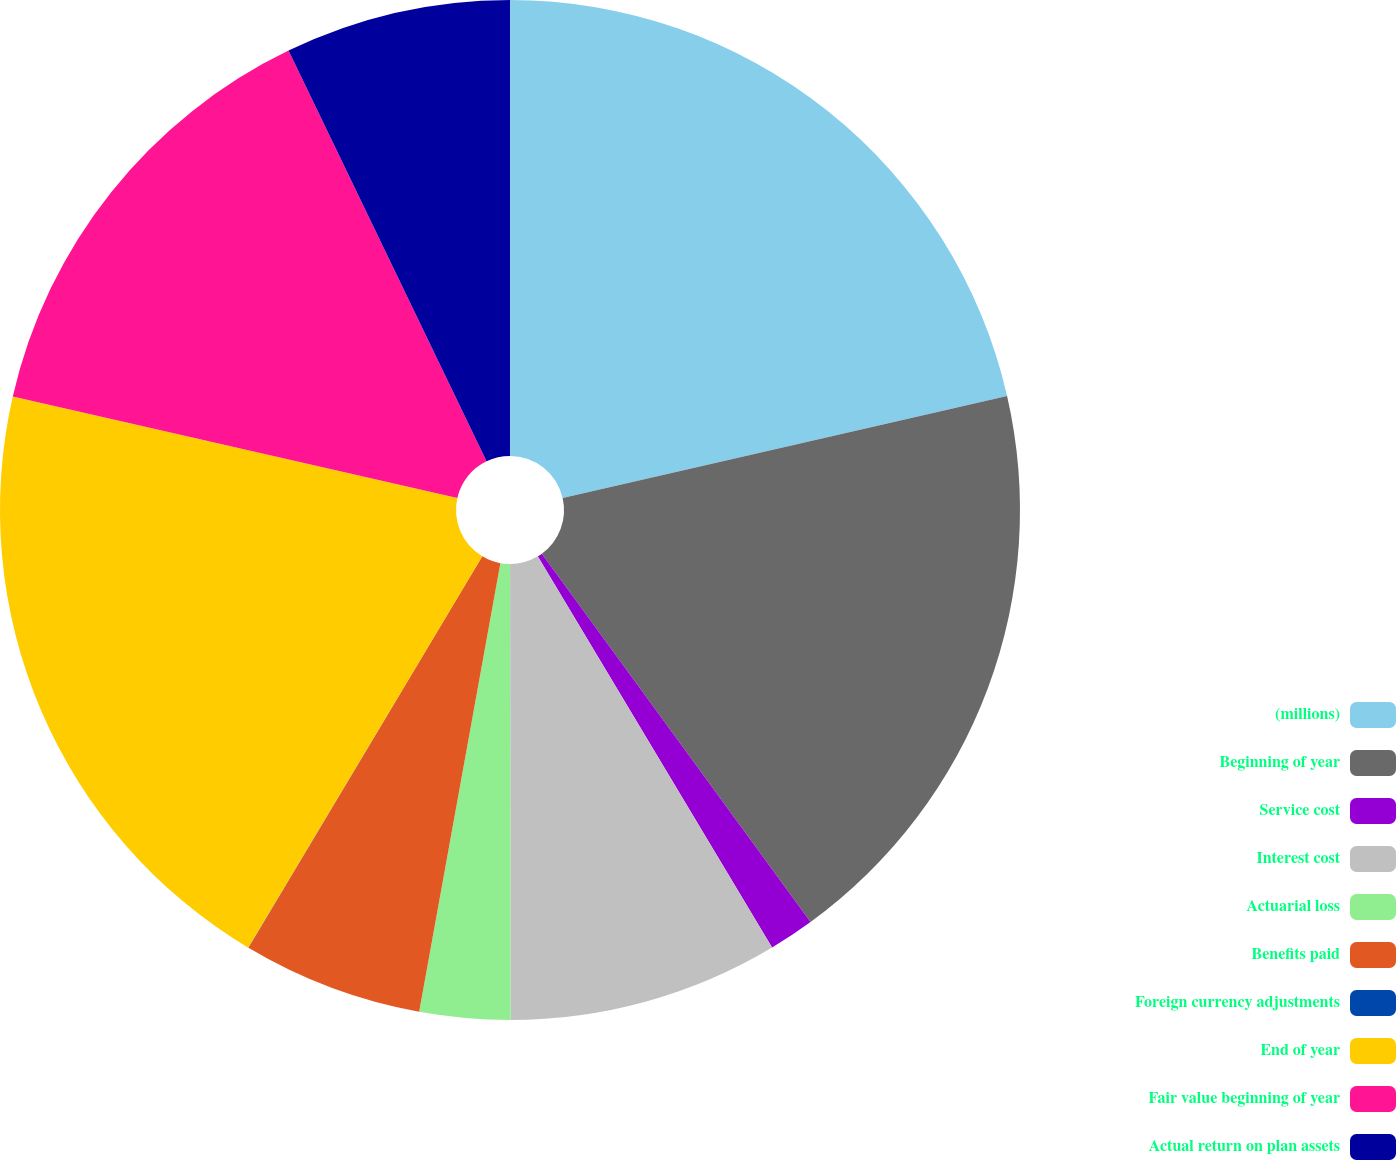Convert chart. <chart><loc_0><loc_0><loc_500><loc_500><pie_chart><fcel>(millions)<fcel>Beginning of year<fcel>Service cost<fcel>Interest cost<fcel>Actuarial loss<fcel>Benefits paid<fcel>Foreign currency adjustments<fcel>End of year<fcel>Fair value beginning of year<fcel>Actual return on plan assets<nl><fcel>21.41%<fcel>18.56%<fcel>1.44%<fcel>8.57%<fcel>2.87%<fcel>5.72%<fcel>0.01%<fcel>19.99%<fcel>14.28%<fcel>7.15%<nl></chart> 